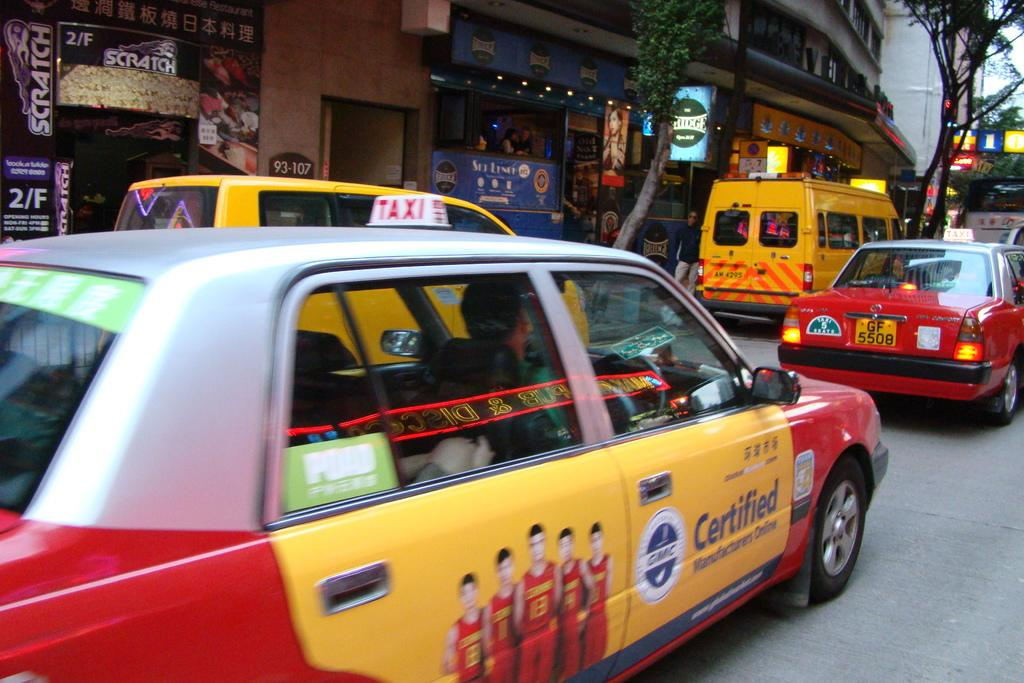<image>
Relay a brief, clear account of the picture shown. A busy street is filled with taxis, and one of them is promoting Certified Manufacturers Online. 